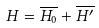Convert formula to latex. <formula><loc_0><loc_0><loc_500><loc_500>H = \overline { H _ { 0 } } + \overline { H ^ { \prime } }</formula> 